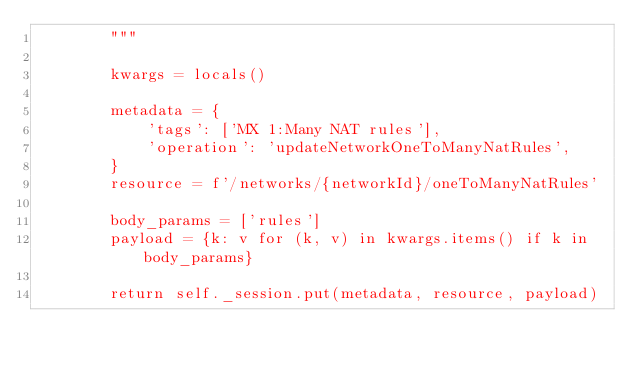<code> <loc_0><loc_0><loc_500><loc_500><_Python_>        """

        kwargs = locals()

        metadata = {
            'tags': ['MX 1:Many NAT rules'],
            'operation': 'updateNetworkOneToManyNatRules',
        }
        resource = f'/networks/{networkId}/oneToManyNatRules'

        body_params = ['rules']
        payload = {k: v for (k, v) in kwargs.items() if k in body_params}

        return self._session.put(metadata, resource, payload)

</code> 